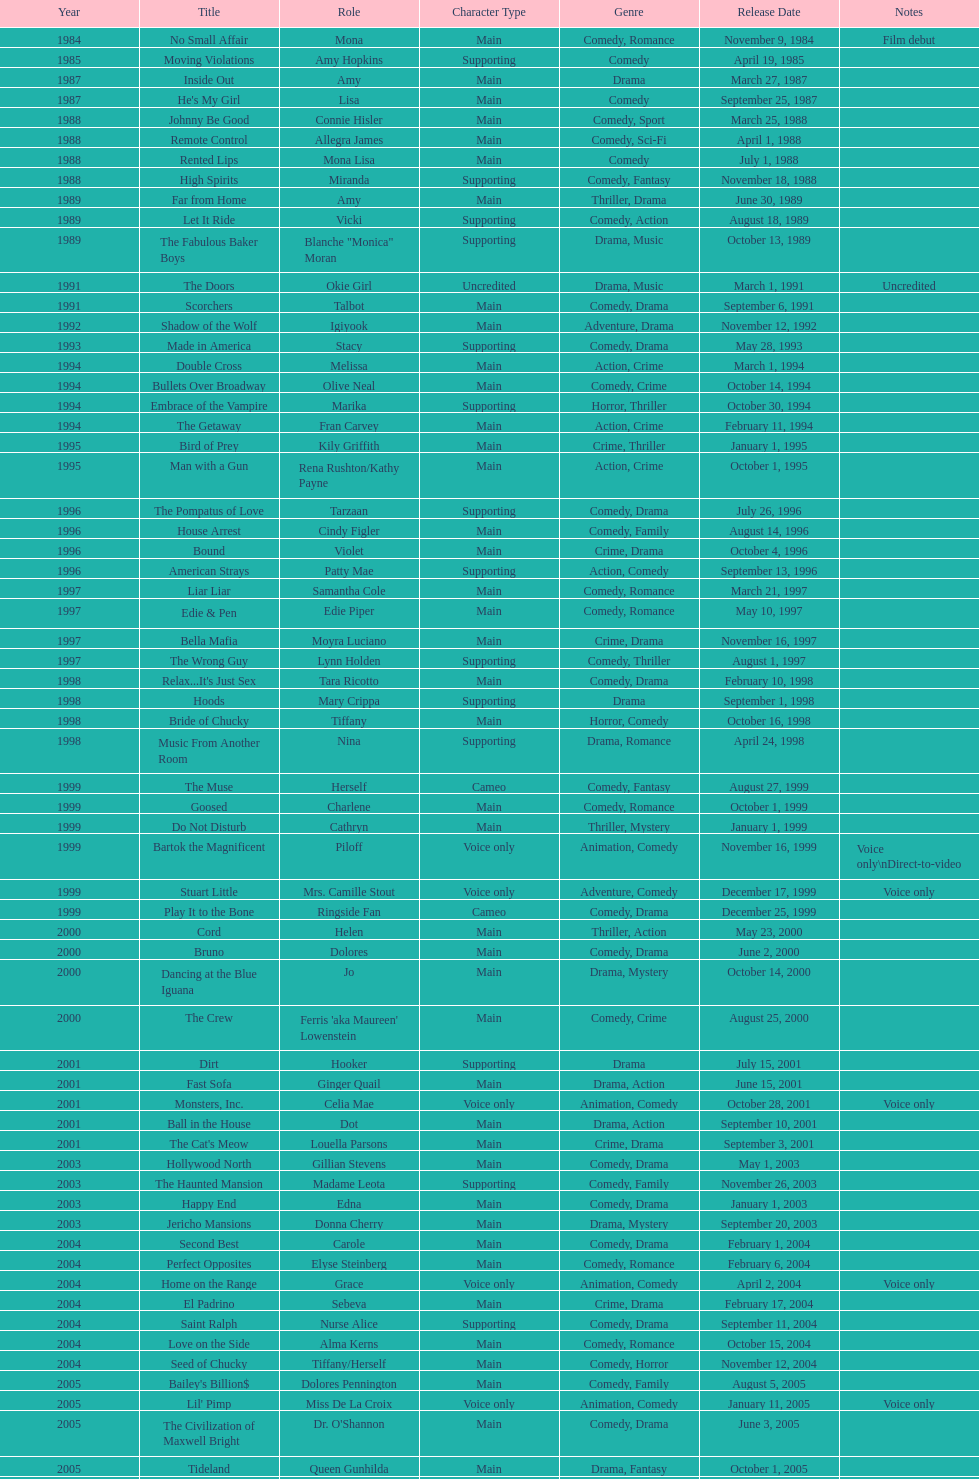How many rolls did jennifer tilly play in the 1980s? 11. 